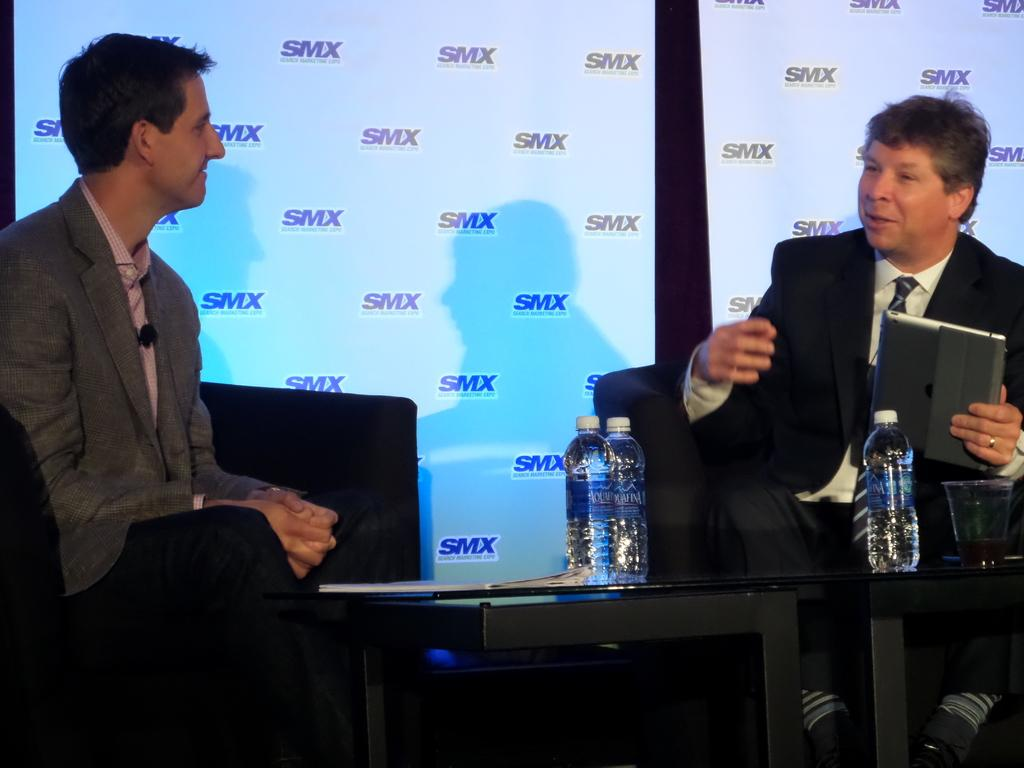How many men are sitting in the image? There are two men sitting on chairs in the image. What is one of the men holding? One man is holding a gadget. What can be found on the table in the image? There are bottles, a glass, and other objects on the table. What is visible in the background of the image? There are banners in the background. What theory is being discussed by the men in the image? There is no indication in the image that the men are discussing a theory. What design elements can be seen in the cemetery in the image? There is no cemetery present in the image. 